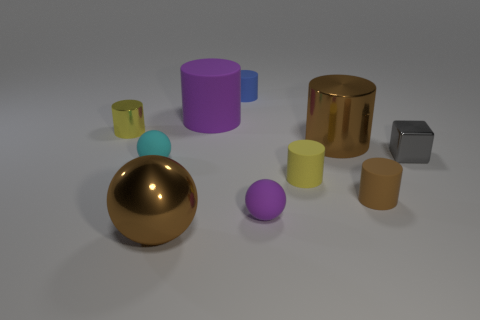What material is the brown object on the left side of the purple cylinder?
Ensure brevity in your answer.  Metal. What number of brown objects have the same shape as the small purple rubber object?
Provide a short and direct response. 1. Does the metallic sphere have the same color as the large shiny cylinder?
Your answer should be very brief. Yes. The brown thing to the left of the brown object behind the gray shiny object that is behind the tiny yellow rubber thing is made of what material?
Give a very brief answer. Metal. Are there any rubber cylinders on the right side of the large purple matte cylinder?
Your answer should be compact. Yes. What shape is the purple rubber thing that is the same size as the cyan rubber object?
Your response must be concise. Sphere. Is the material of the small blue cylinder the same as the purple ball?
Provide a short and direct response. Yes. How many metallic things are either gray blocks or tiny yellow objects?
Offer a very short reply. 2. What shape is the object that is the same color as the tiny metal cylinder?
Provide a succinct answer. Cylinder. There is a shiny cylinder that is right of the big purple cylinder; is it the same color as the big metal sphere?
Keep it short and to the point. Yes. 